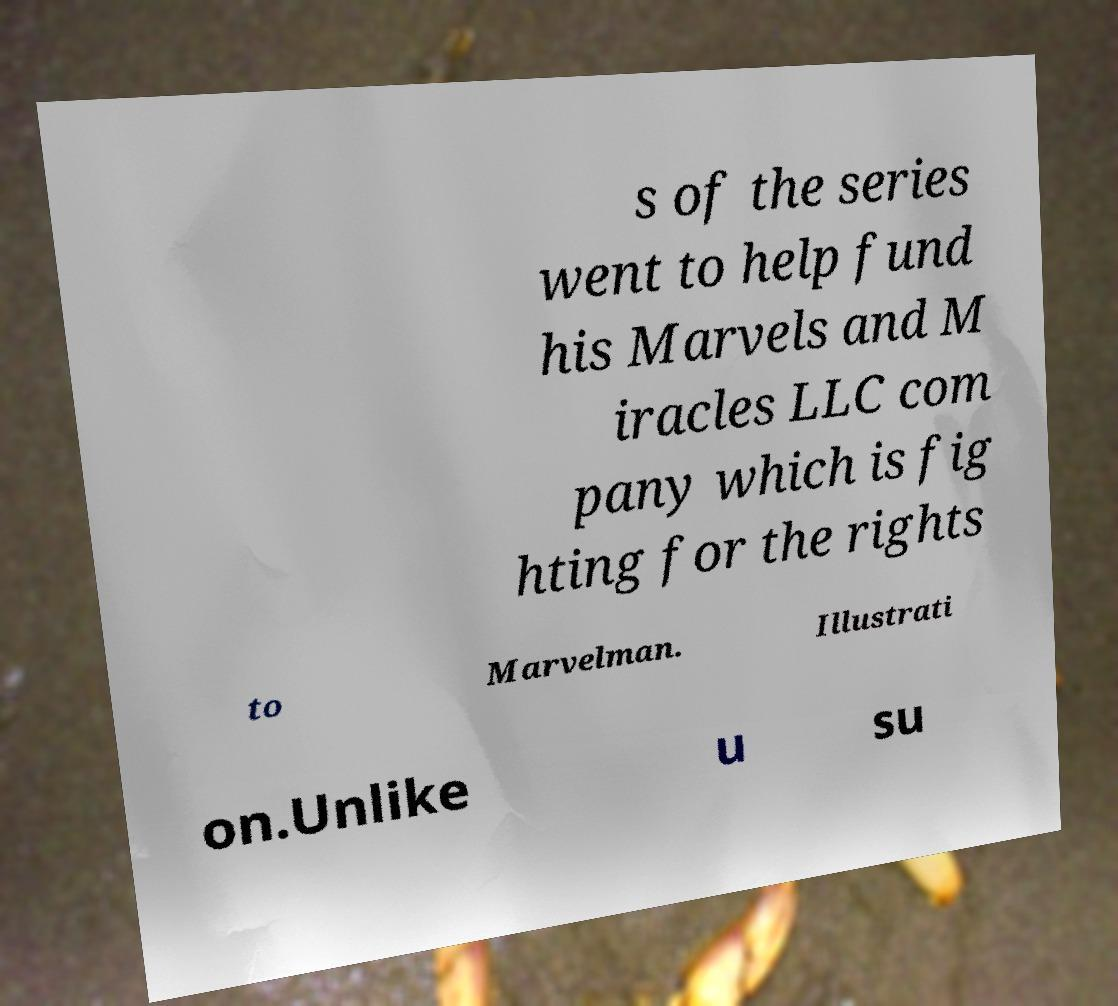Could you assist in decoding the text presented in this image and type it out clearly? s of the series went to help fund his Marvels and M iracles LLC com pany which is fig hting for the rights to Marvelman. Illustrati on.Unlike u su 